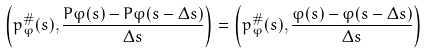Convert formula to latex. <formula><loc_0><loc_0><loc_500><loc_500>\left ( p ^ { \# } _ { \varphi } ( s ) , \frac { P \varphi ( s ) - P \varphi ( s - \Delta s ) } { \Delta s } \right ) = \left ( p ^ { \# } _ { \varphi } ( s ) , \frac { \varphi ( s ) - \varphi ( s - \Delta s ) } { \Delta s } \right )</formula> 